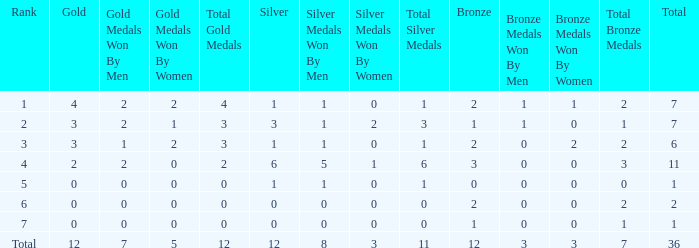What is the highest number of silver medals for a team with total less than 1? None. 